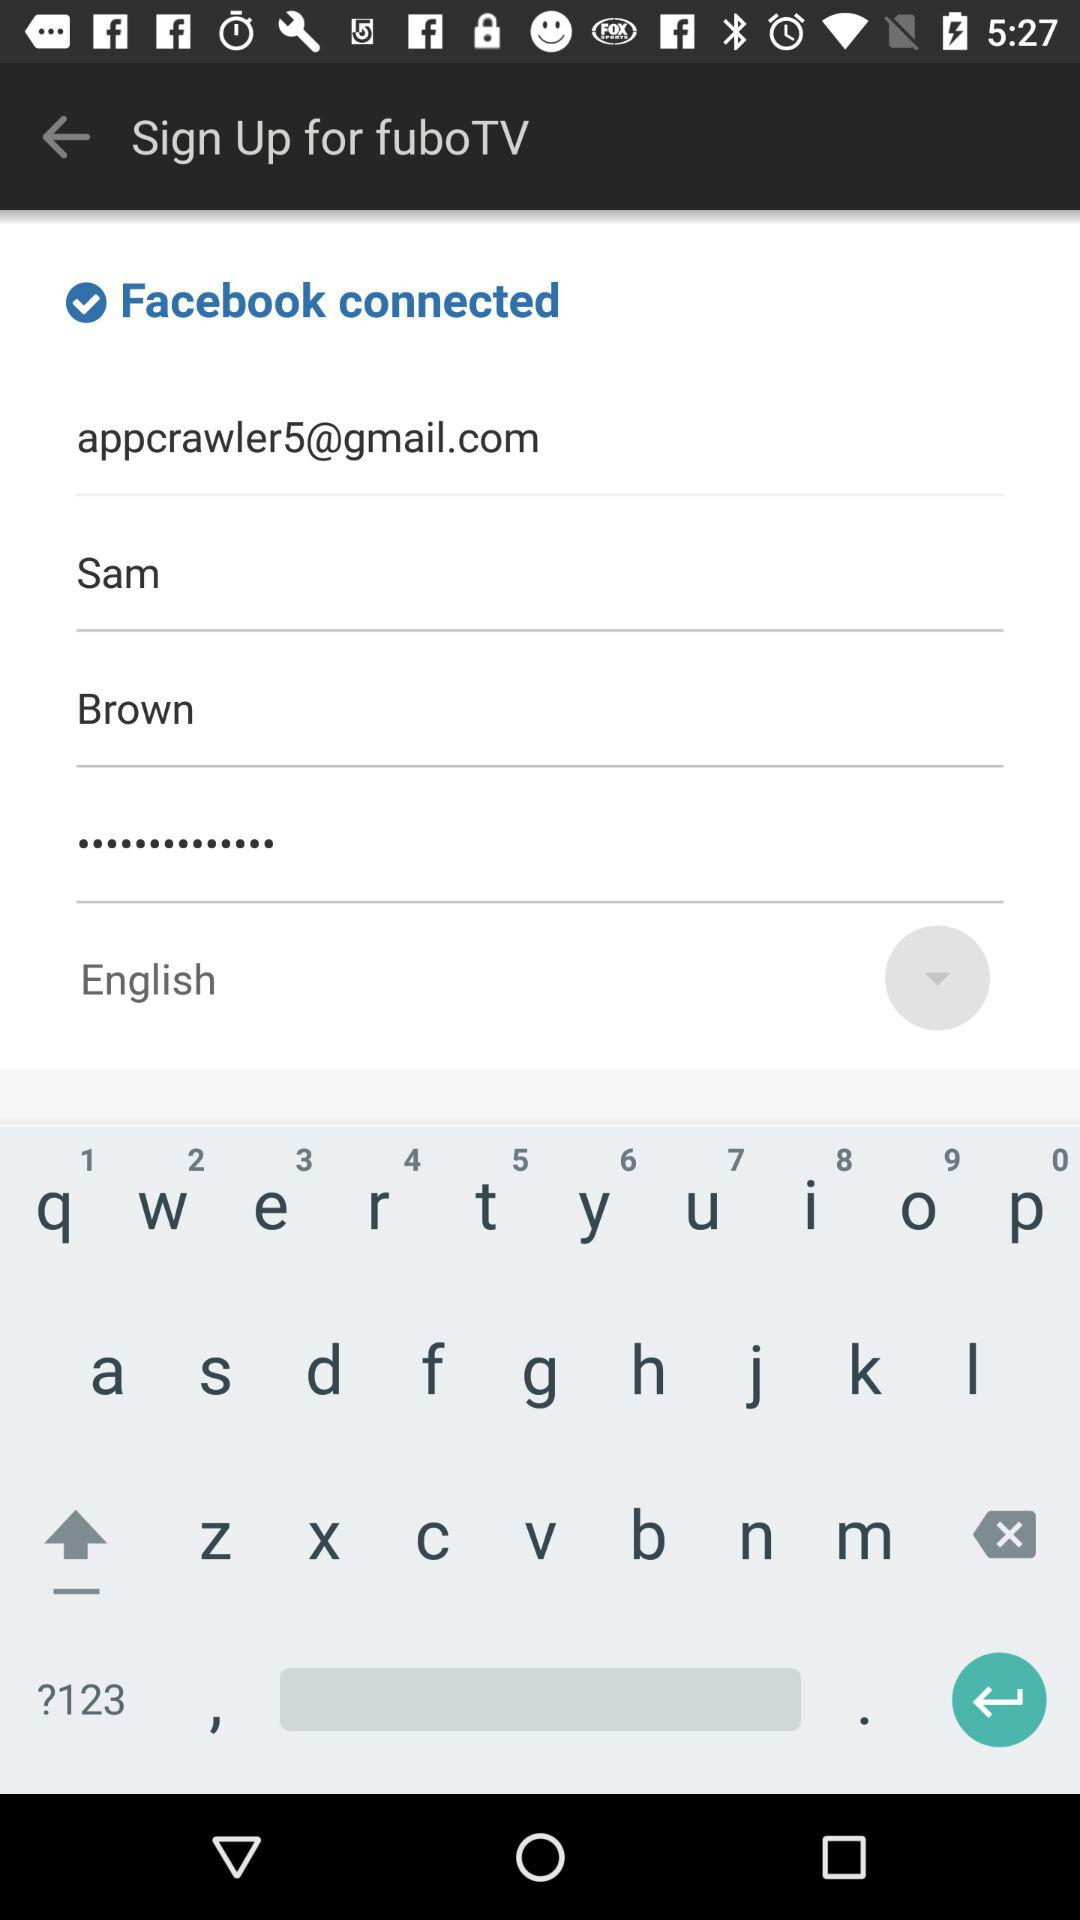What application is connected? The application is "Facebook". 